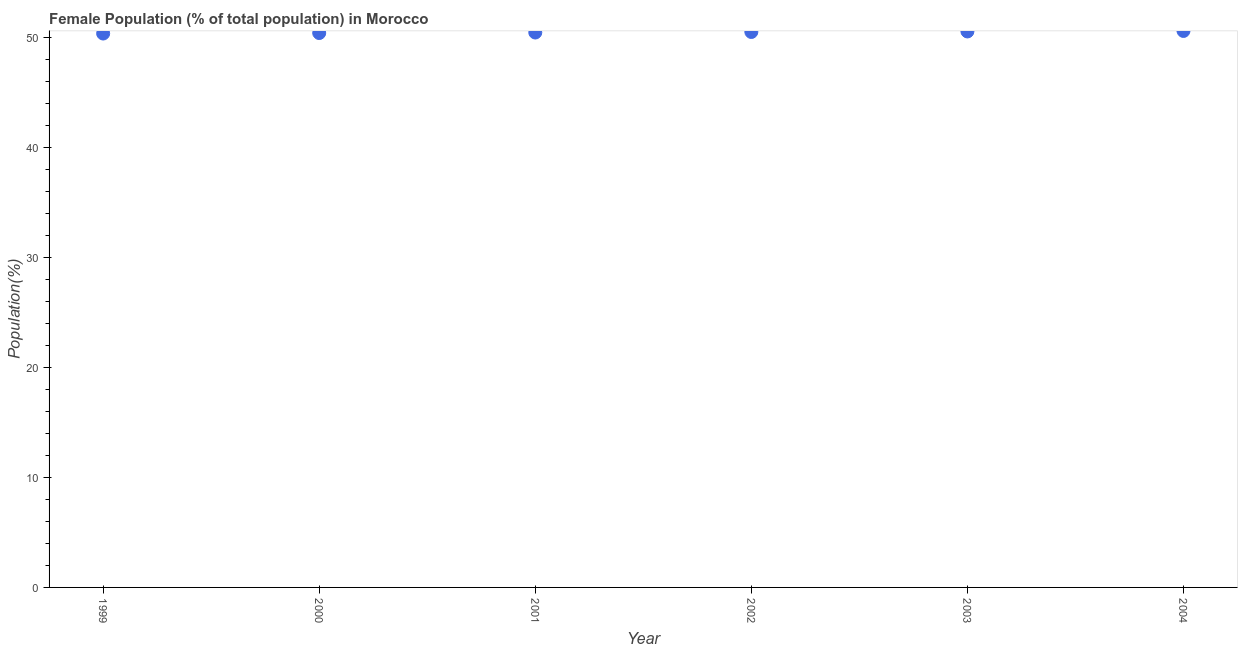What is the female population in 2004?
Keep it short and to the point. 50.64. Across all years, what is the maximum female population?
Offer a terse response. 50.64. Across all years, what is the minimum female population?
Your answer should be compact. 50.4. What is the sum of the female population?
Keep it short and to the point. 303.12. What is the difference between the female population in 2002 and 2003?
Keep it short and to the point. -0.05. What is the average female population per year?
Provide a succinct answer. 50.52. What is the median female population?
Provide a short and direct response. 50.52. In how many years, is the female population greater than 6 %?
Your answer should be compact. 6. What is the ratio of the female population in 2000 to that in 2004?
Give a very brief answer. 1. Is the female population in 1999 less than that in 2002?
Your response must be concise. Yes. What is the difference between the highest and the second highest female population?
Provide a short and direct response. 0.05. Is the sum of the female population in 1999 and 2003 greater than the maximum female population across all years?
Your answer should be compact. Yes. What is the difference between the highest and the lowest female population?
Give a very brief answer. 0.23. In how many years, is the female population greater than the average female population taken over all years?
Keep it short and to the point. 3. How many years are there in the graph?
Keep it short and to the point. 6. What is the difference between two consecutive major ticks on the Y-axis?
Provide a succinct answer. 10. Are the values on the major ticks of Y-axis written in scientific E-notation?
Your answer should be very brief. No. What is the title of the graph?
Provide a short and direct response. Female Population (% of total population) in Morocco. What is the label or title of the X-axis?
Give a very brief answer. Year. What is the label or title of the Y-axis?
Offer a terse response. Population(%). What is the Population(%) in 1999?
Provide a succinct answer. 50.4. What is the Population(%) in 2000?
Keep it short and to the point. 50.45. What is the Population(%) in 2001?
Ensure brevity in your answer.  50.5. What is the Population(%) in 2002?
Ensure brevity in your answer.  50.54. What is the Population(%) in 2003?
Keep it short and to the point. 50.59. What is the Population(%) in 2004?
Offer a terse response. 50.64. What is the difference between the Population(%) in 1999 and 2000?
Offer a very short reply. -0.04. What is the difference between the Population(%) in 1999 and 2001?
Ensure brevity in your answer.  -0.09. What is the difference between the Population(%) in 1999 and 2002?
Provide a succinct answer. -0.14. What is the difference between the Population(%) in 1999 and 2003?
Your answer should be compact. -0.19. What is the difference between the Population(%) in 1999 and 2004?
Your answer should be compact. -0.23. What is the difference between the Population(%) in 2000 and 2001?
Your answer should be compact. -0.05. What is the difference between the Population(%) in 2000 and 2002?
Make the answer very short. -0.1. What is the difference between the Population(%) in 2000 and 2003?
Your response must be concise. -0.14. What is the difference between the Population(%) in 2000 and 2004?
Your answer should be very brief. -0.19. What is the difference between the Population(%) in 2001 and 2002?
Offer a very short reply. -0.05. What is the difference between the Population(%) in 2001 and 2003?
Your response must be concise. -0.1. What is the difference between the Population(%) in 2001 and 2004?
Offer a very short reply. -0.14. What is the difference between the Population(%) in 2002 and 2003?
Provide a succinct answer. -0.05. What is the difference between the Population(%) in 2002 and 2004?
Make the answer very short. -0.09. What is the difference between the Population(%) in 2003 and 2004?
Your response must be concise. -0.05. What is the ratio of the Population(%) in 1999 to that in 2003?
Provide a short and direct response. 1. What is the ratio of the Population(%) in 2000 to that in 2001?
Ensure brevity in your answer.  1. What is the ratio of the Population(%) in 2000 to that in 2003?
Make the answer very short. 1. What is the ratio of the Population(%) in 2000 to that in 2004?
Offer a very short reply. 1. What is the ratio of the Population(%) in 2001 to that in 2002?
Give a very brief answer. 1. What is the ratio of the Population(%) in 2001 to that in 2003?
Keep it short and to the point. 1. What is the ratio of the Population(%) in 2001 to that in 2004?
Offer a very short reply. 1. What is the ratio of the Population(%) in 2003 to that in 2004?
Your answer should be very brief. 1. 